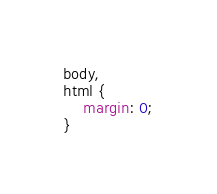Convert code to text. <code><loc_0><loc_0><loc_500><loc_500><_CSS_>body,
html {
	margin: 0;
}
</code> 